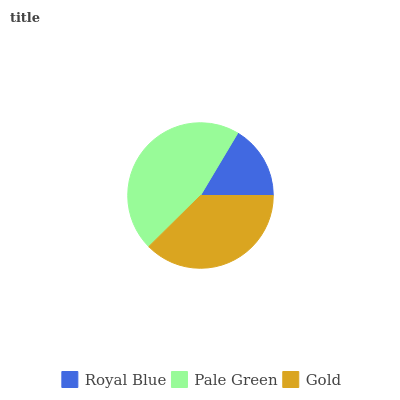Is Royal Blue the minimum?
Answer yes or no. Yes. Is Pale Green the maximum?
Answer yes or no. Yes. Is Gold the minimum?
Answer yes or no. No. Is Gold the maximum?
Answer yes or no. No. Is Pale Green greater than Gold?
Answer yes or no. Yes. Is Gold less than Pale Green?
Answer yes or no. Yes. Is Gold greater than Pale Green?
Answer yes or no. No. Is Pale Green less than Gold?
Answer yes or no. No. Is Gold the high median?
Answer yes or no. Yes. Is Gold the low median?
Answer yes or no. Yes. Is Royal Blue the high median?
Answer yes or no. No. Is Royal Blue the low median?
Answer yes or no. No. 